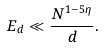Convert formula to latex. <formula><loc_0><loc_0><loc_500><loc_500>E _ { d } \ll \frac { N ^ { 1 - 5 \eta } } { d } .</formula> 